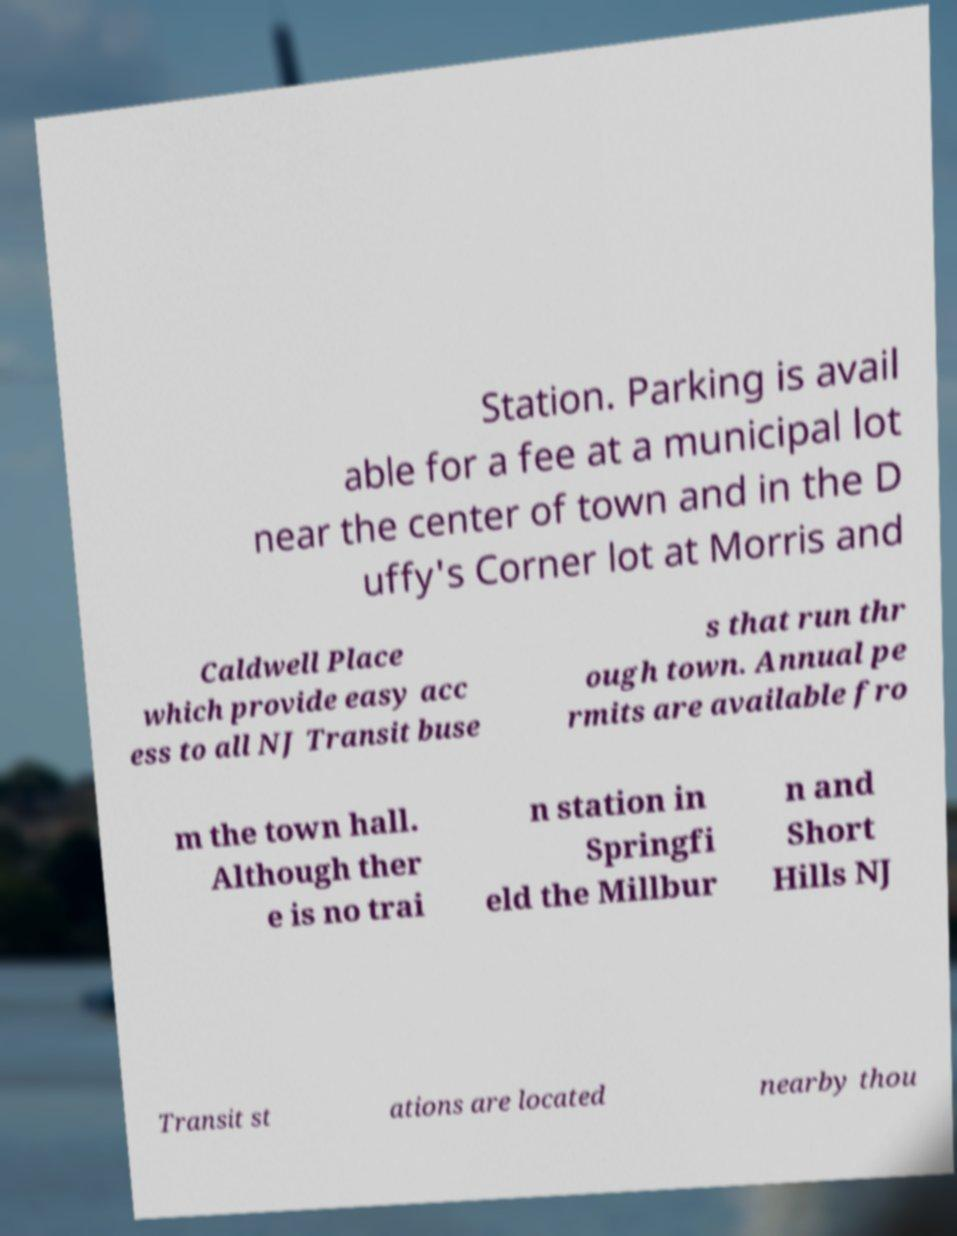Could you assist in decoding the text presented in this image and type it out clearly? Station. Parking is avail able for a fee at a municipal lot near the center of town and in the D uffy's Corner lot at Morris and Caldwell Place which provide easy acc ess to all NJ Transit buse s that run thr ough town. Annual pe rmits are available fro m the town hall. Although ther e is no trai n station in Springfi eld the Millbur n and Short Hills NJ Transit st ations are located nearby thou 